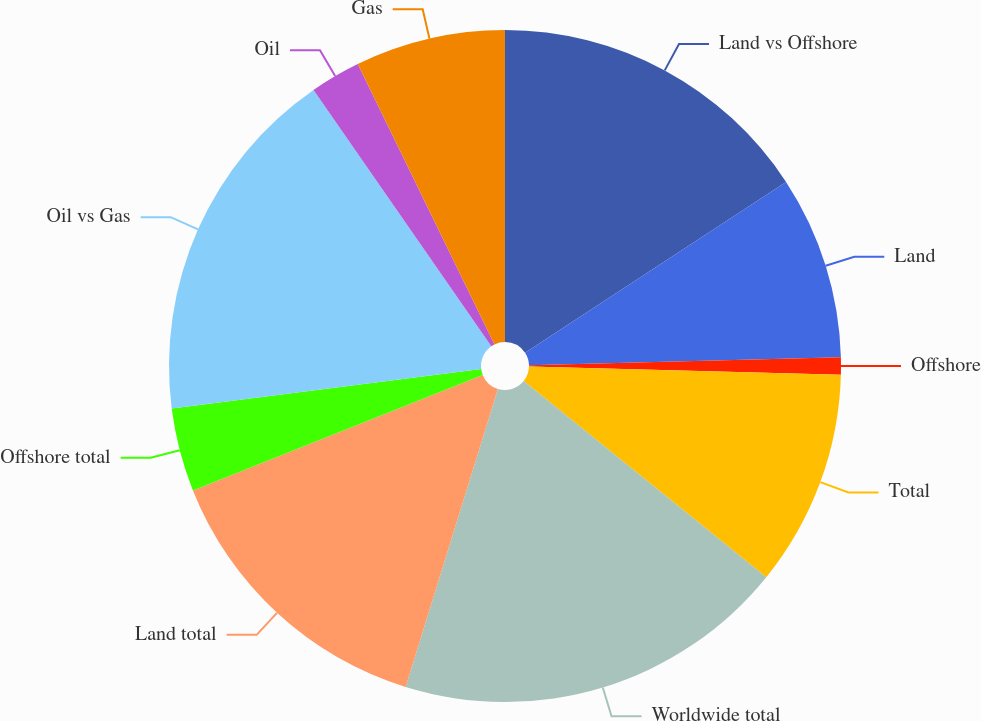Convert chart to OTSL. <chart><loc_0><loc_0><loc_500><loc_500><pie_chart><fcel>Land vs Offshore<fcel>Land<fcel>Offshore<fcel>Total<fcel>Worldwide total<fcel>Land total<fcel>Offshore total<fcel>Oil vs Gas<fcel>Oil<fcel>Gas<nl><fcel>15.77%<fcel>8.81%<fcel>0.83%<fcel>10.41%<fcel>18.96%<fcel>14.18%<fcel>4.02%<fcel>17.37%<fcel>2.43%<fcel>7.22%<nl></chart> 